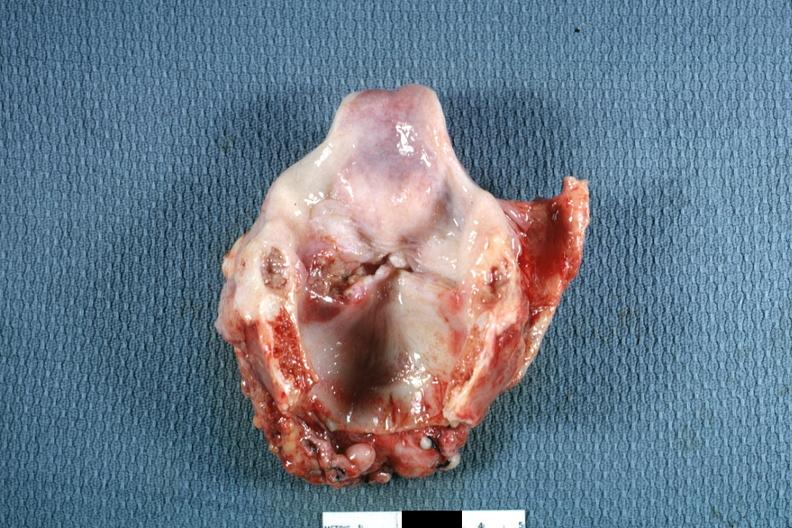what does this image show?
Answer the question using a single word or phrase. Ulcerative lesion left true cord quite good 